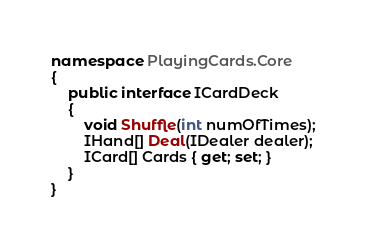<code> <loc_0><loc_0><loc_500><loc_500><_C#_>namespace PlayingCards.Core
{
    public interface ICardDeck
    {
        void Shuffle(int numOfTimes);
        IHand[] Deal(IDealer dealer);
        ICard[] Cards { get; set; }
    }
}
</code> 